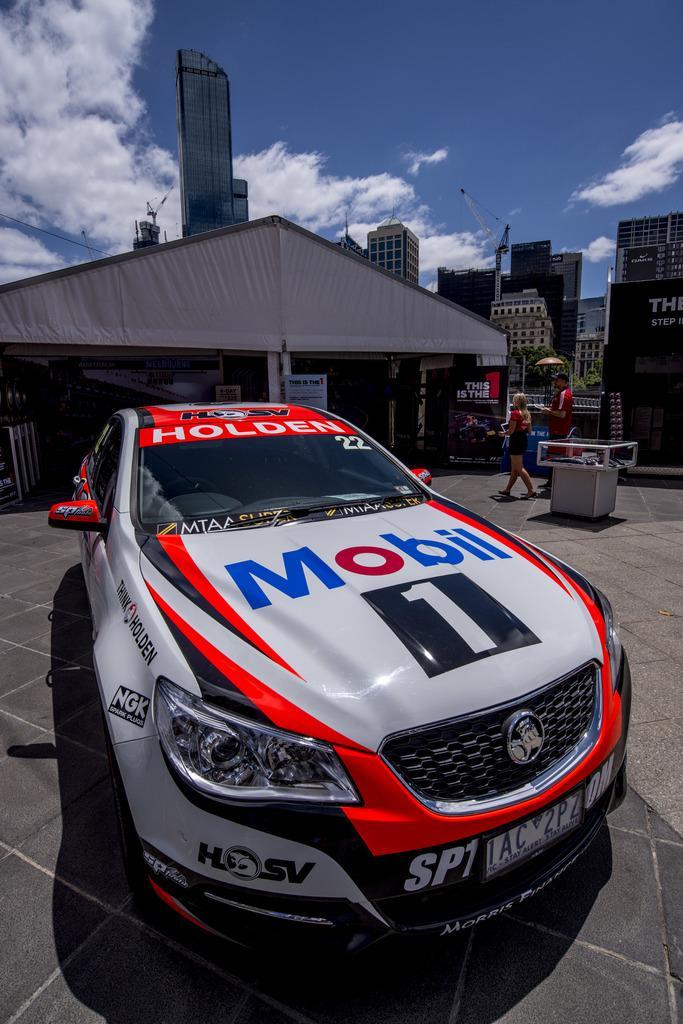In one or two sentences, can you explain what this image depicts? In the picture we can see a car which is in different color, in the background of the picture there are two persons walking and there are some houses and clear sky. 